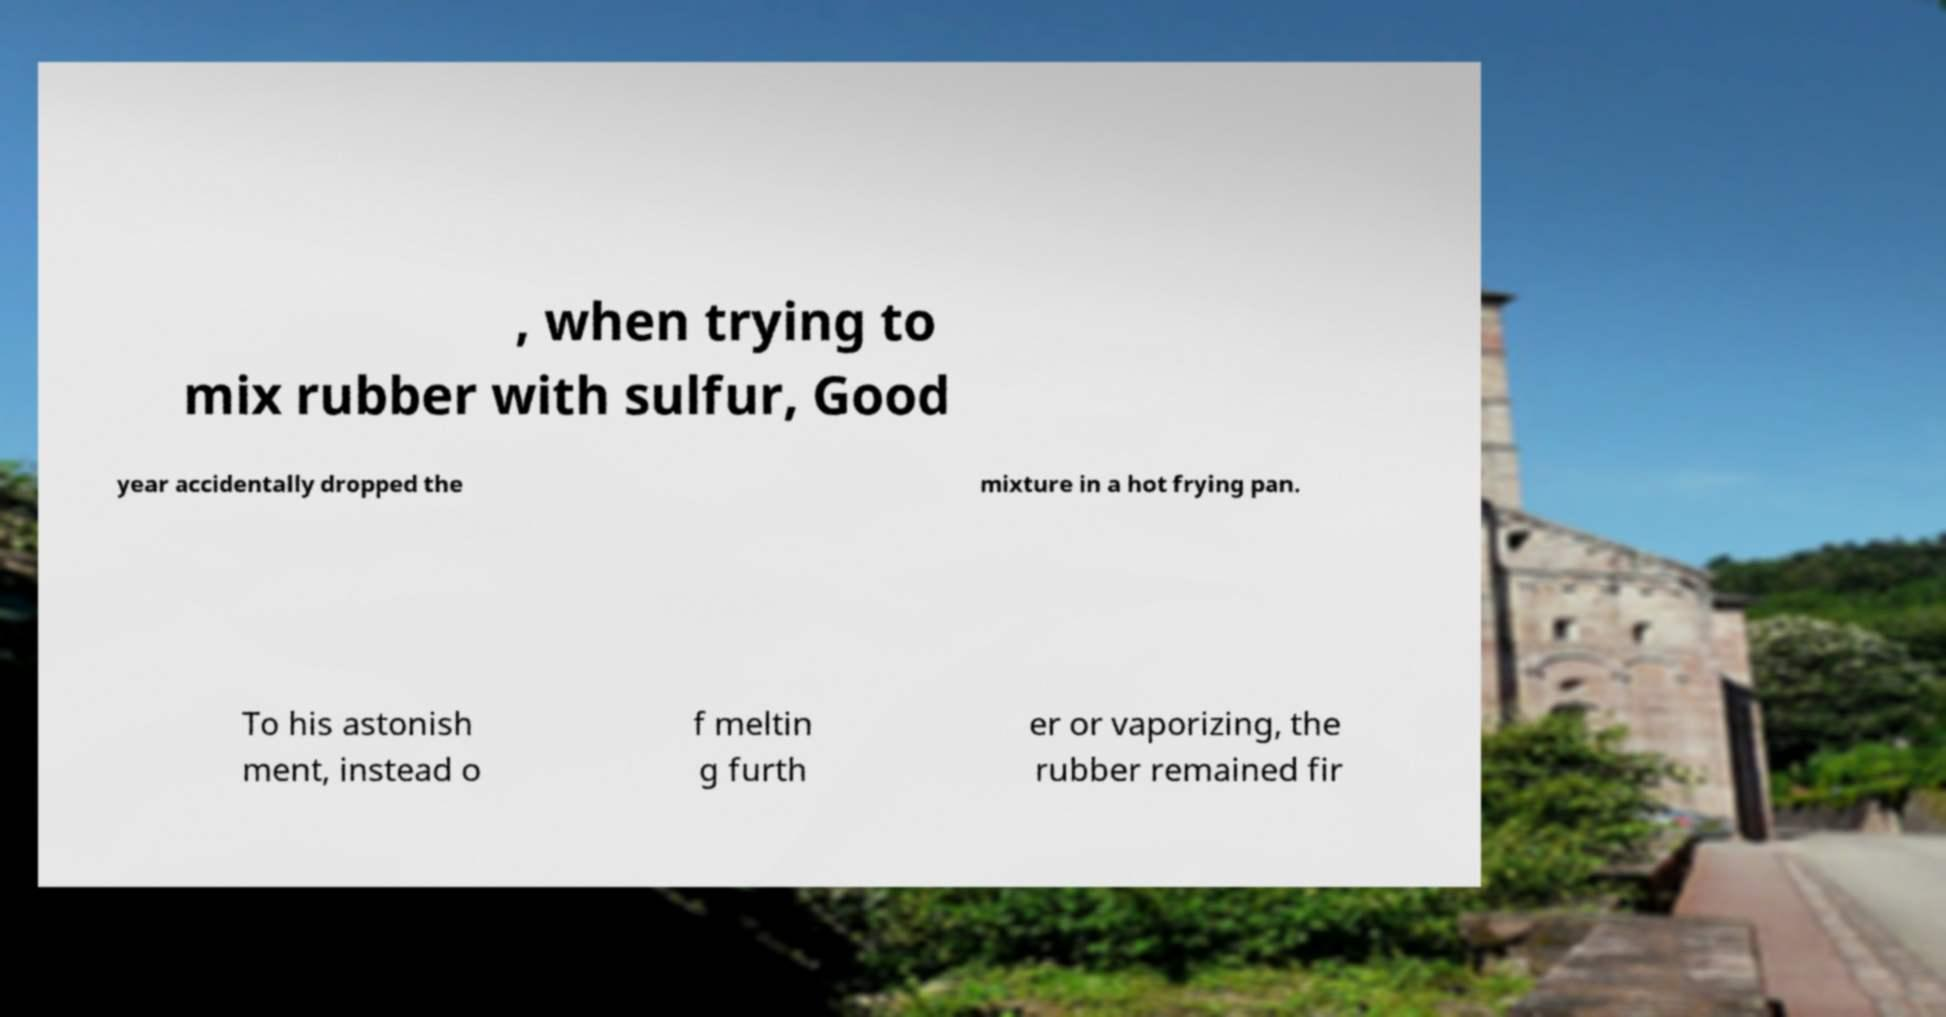Could you extract and type out the text from this image? , when trying to mix rubber with sulfur, Good year accidentally dropped the mixture in a hot frying pan. To his astonish ment, instead o f meltin g furth er or vaporizing, the rubber remained fir 